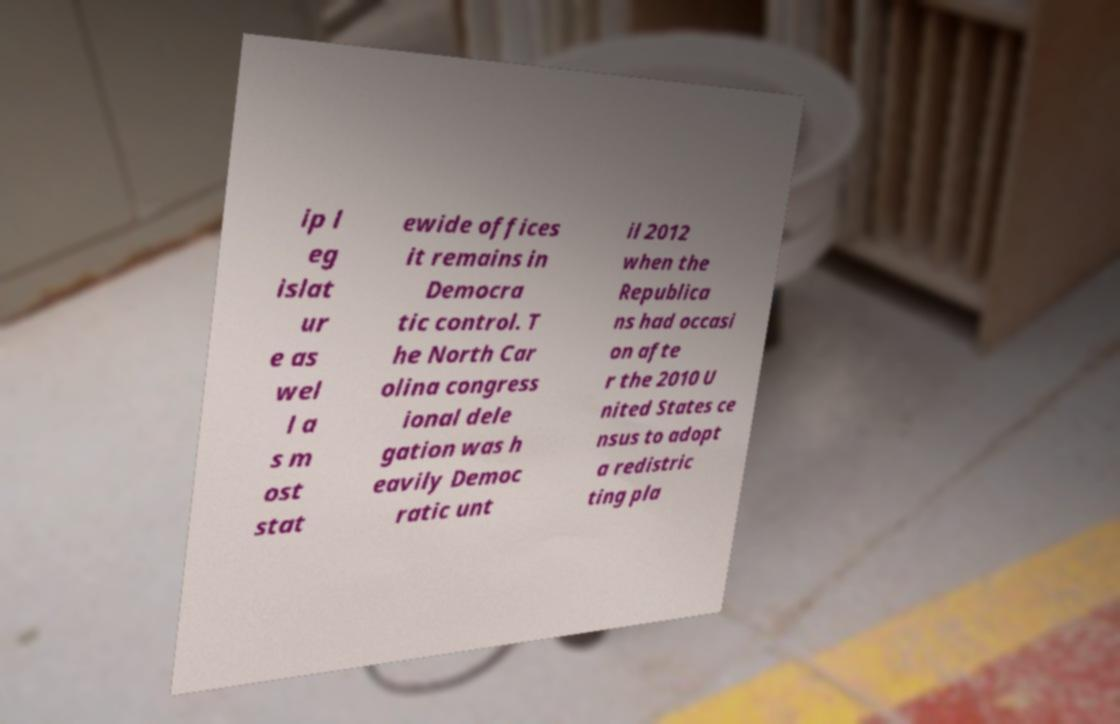For documentation purposes, I need the text within this image transcribed. Could you provide that? ip l eg islat ur e as wel l a s m ost stat ewide offices it remains in Democra tic control. T he North Car olina congress ional dele gation was h eavily Democ ratic unt il 2012 when the Republica ns had occasi on afte r the 2010 U nited States ce nsus to adopt a redistric ting pla 